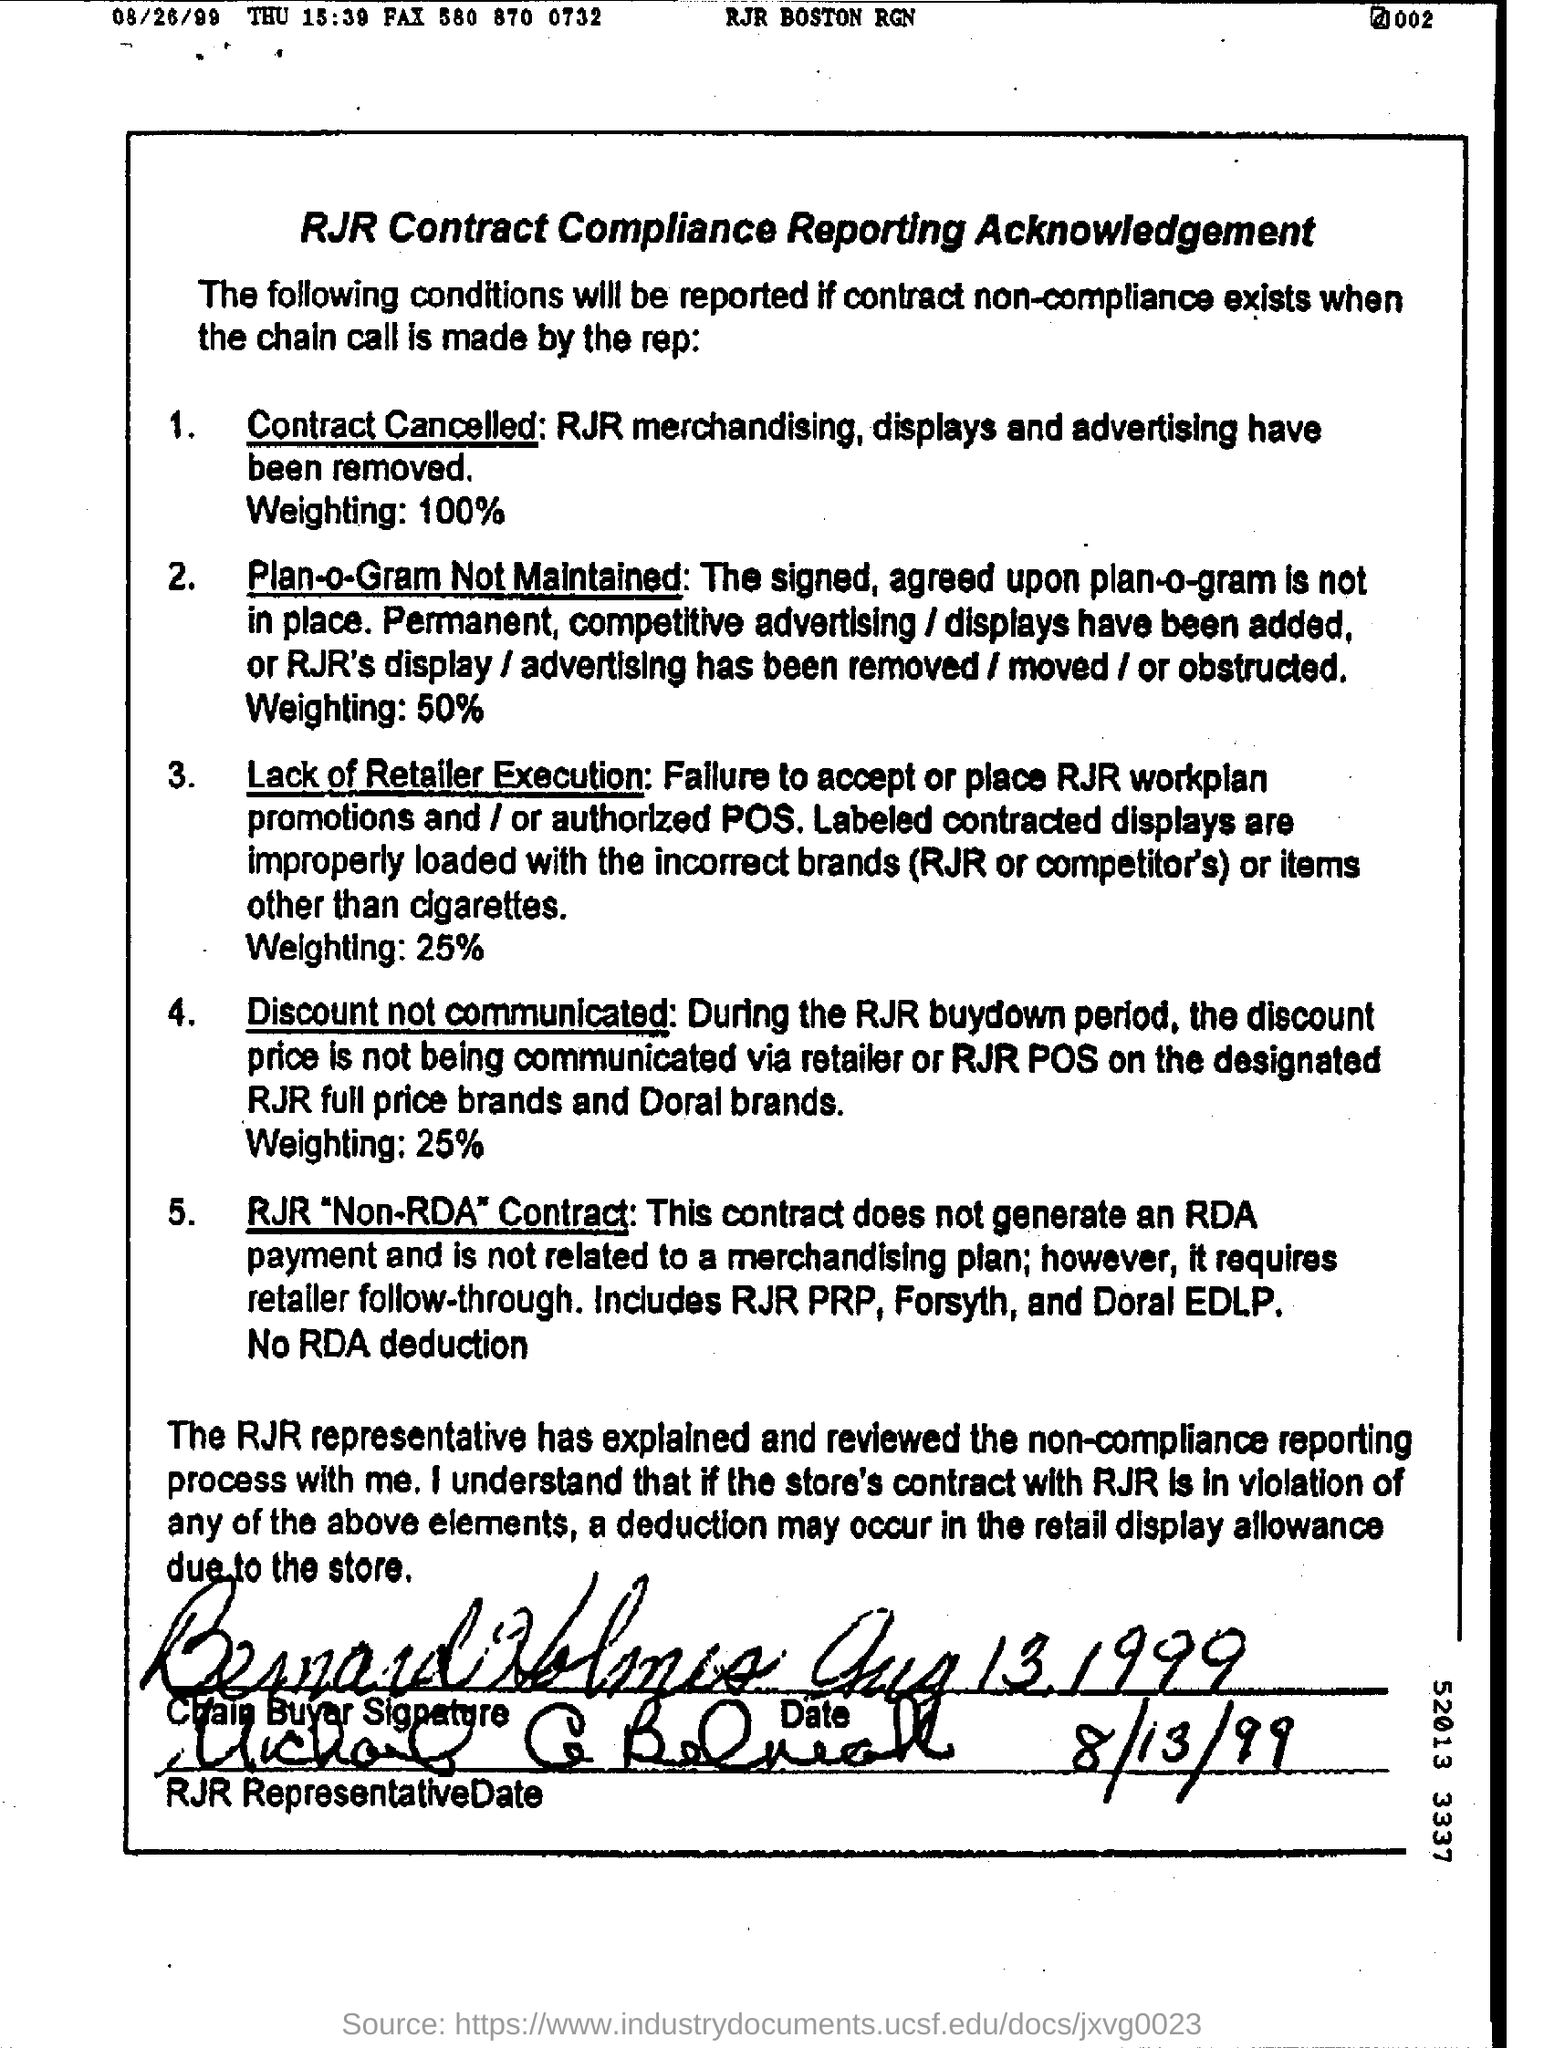How much is % of weighting under contract cancelled ?
Ensure brevity in your answer.  100%. What day of the week is 08/26/99 ?
Keep it short and to the point. THU. 